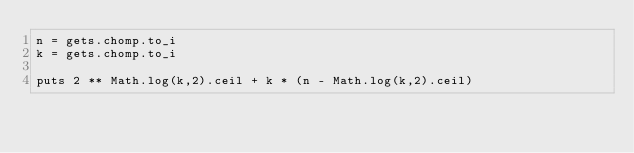Convert code to text. <code><loc_0><loc_0><loc_500><loc_500><_Ruby_>n = gets.chomp.to_i
k = gets.chomp.to_i

puts 2 ** Math.log(k,2).ceil + k * (n - Math.log(k,2).ceil)</code> 